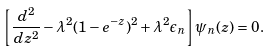<formula> <loc_0><loc_0><loc_500><loc_500>\left [ \frac { d ^ { 2 } } { d z ^ { 2 } } - \lambda ^ { 2 } ( 1 - e ^ { - z } ) ^ { 2 } + \lambda ^ { 2 } \epsilon _ { n } \right ] \psi _ { n } ( z ) = 0 .</formula> 